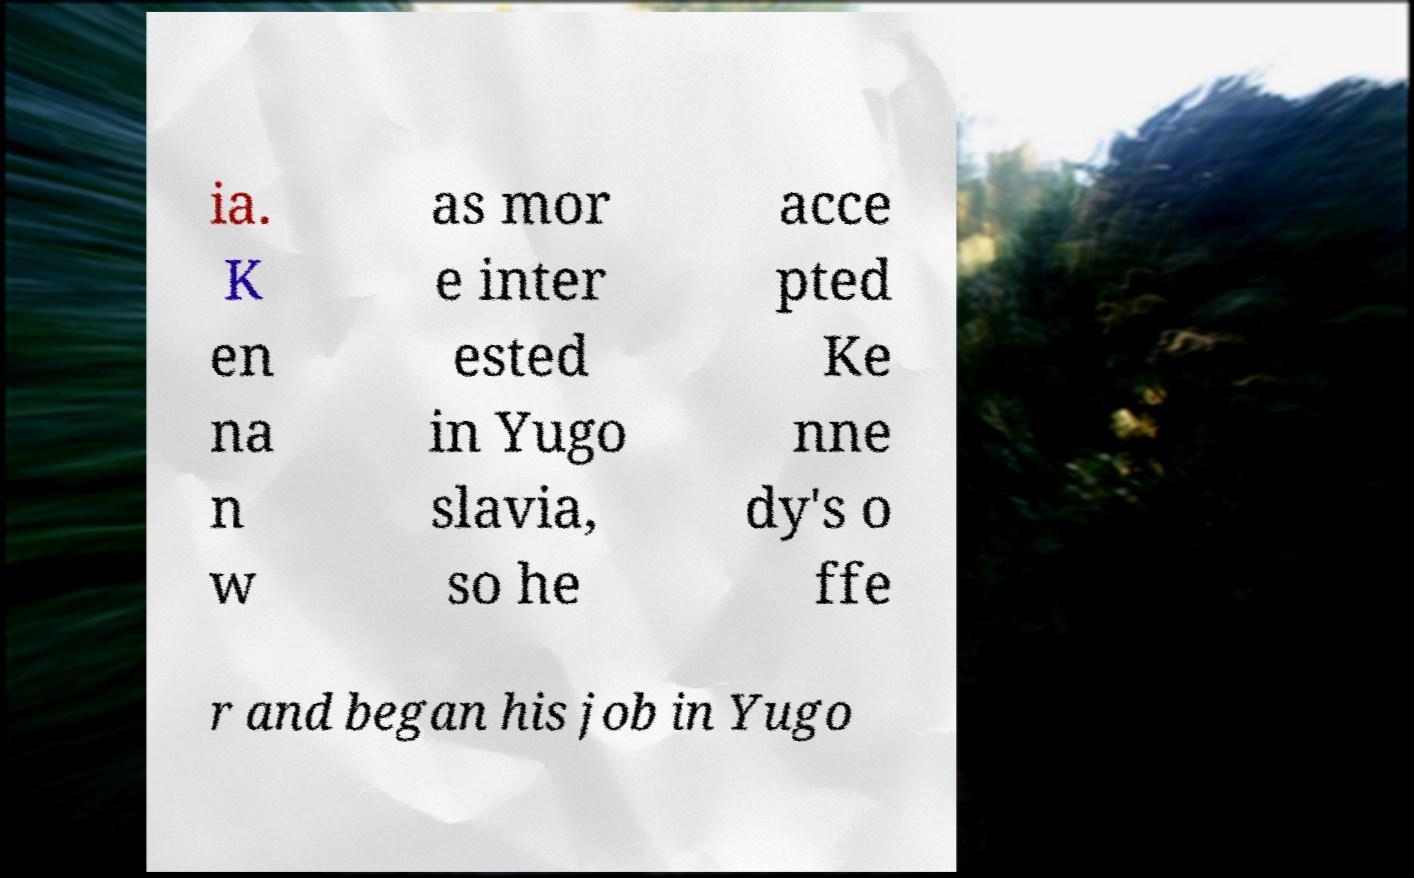What messages or text are displayed in this image? I need them in a readable, typed format. ia. K en na n w as mor e inter ested in Yugo slavia, so he acce pted Ke nne dy's o ffe r and began his job in Yugo 